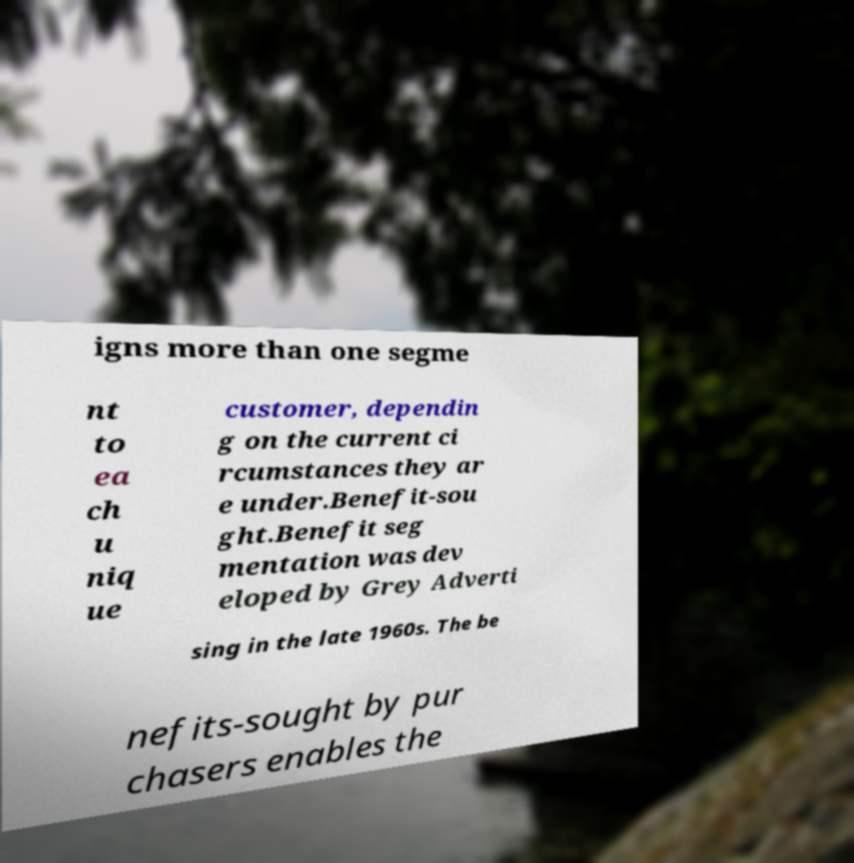I need the written content from this picture converted into text. Can you do that? igns more than one segme nt to ea ch u niq ue customer, dependin g on the current ci rcumstances they ar e under.Benefit-sou ght.Benefit seg mentation was dev eloped by Grey Adverti sing in the late 1960s. The be nefits-sought by pur chasers enables the 